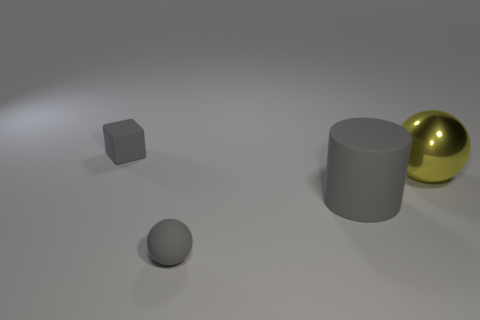Are there any other things that have the same material as the large yellow ball?
Your answer should be compact. No. Is the number of metal spheres that are behind the big cylinder greater than the number of tiny yellow metal spheres?
Your answer should be compact. Yes. Is there anything else that has the same color as the shiny sphere?
Your response must be concise. No. There is a tiny gray object that is made of the same material as the gray ball; what is its shape?
Your answer should be compact. Cube. Do the small gray object that is behind the rubber sphere and the big yellow sphere have the same material?
Offer a very short reply. No. There is a large rubber thing that is the same color as the block; what shape is it?
Keep it short and to the point. Cylinder. There is a tiny object that is in front of the cylinder; is it the same color as the rubber cylinder right of the block?
Make the answer very short. Yes. What number of things are both on the left side of the gray rubber cylinder and behind the large gray matte thing?
Your response must be concise. 1. What material is the large yellow thing?
Keep it short and to the point. Metal. What is the shape of the object that is the same size as the rubber sphere?
Ensure brevity in your answer.  Cube. 